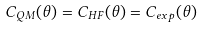Convert formula to latex. <formula><loc_0><loc_0><loc_500><loc_500>C _ { Q M } ( \theta ) = C _ { H F } ( \theta ) = C _ { e x p } ( \theta )</formula> 